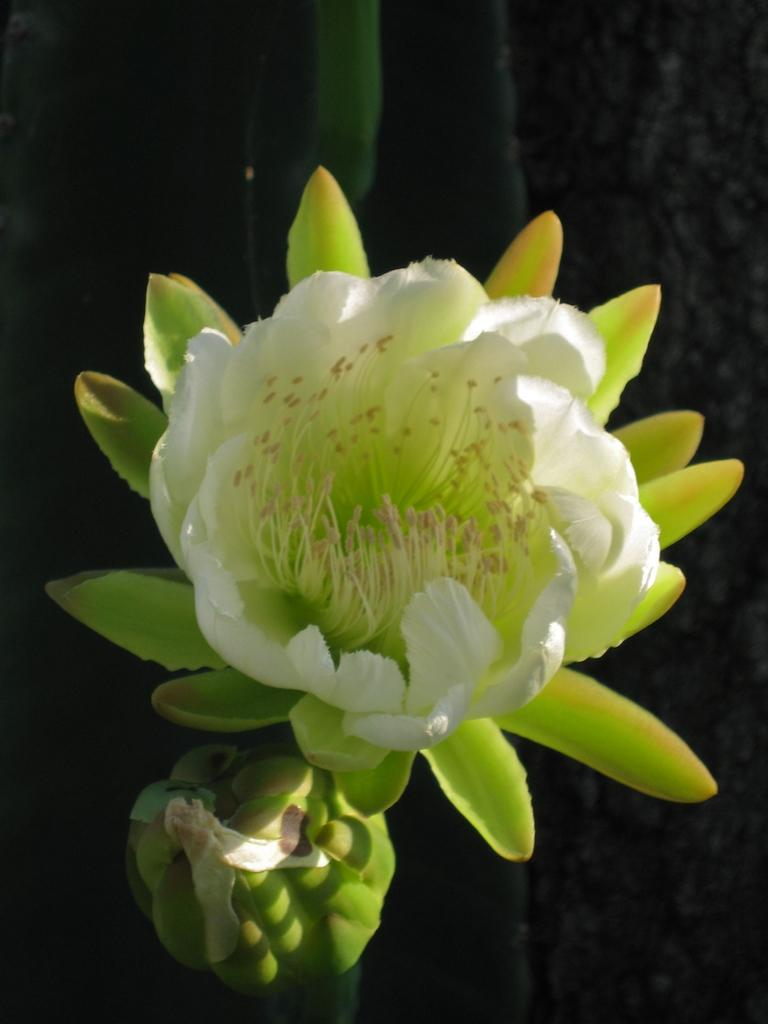What is the main subject of the image? The main subject of the image is a flower. Can you describe the colors of the flower? The flower has white and green colors. What type of soup is being served in the image? There is no soup present in the image; it features a flower with white and green colors. How many toes can be seen on the flower in the image? There are no toes visible in the image, as it features a flower and not a person or animal. 